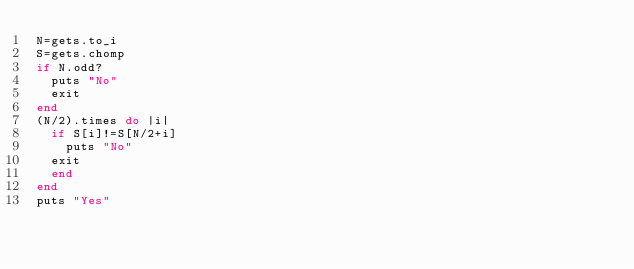Convert code to text. <code><loc_0><loc_0><loc_500><loc_500><_Ruby_>N=gets.to_i
S=gets.chomp
if N.odd?
  puts "No"
  exit
end
(N/2).times do |i|
  if S[i]!=S[N/2+i]
    puts "No"
	exit
  end
end
puts "Yes"</code> 